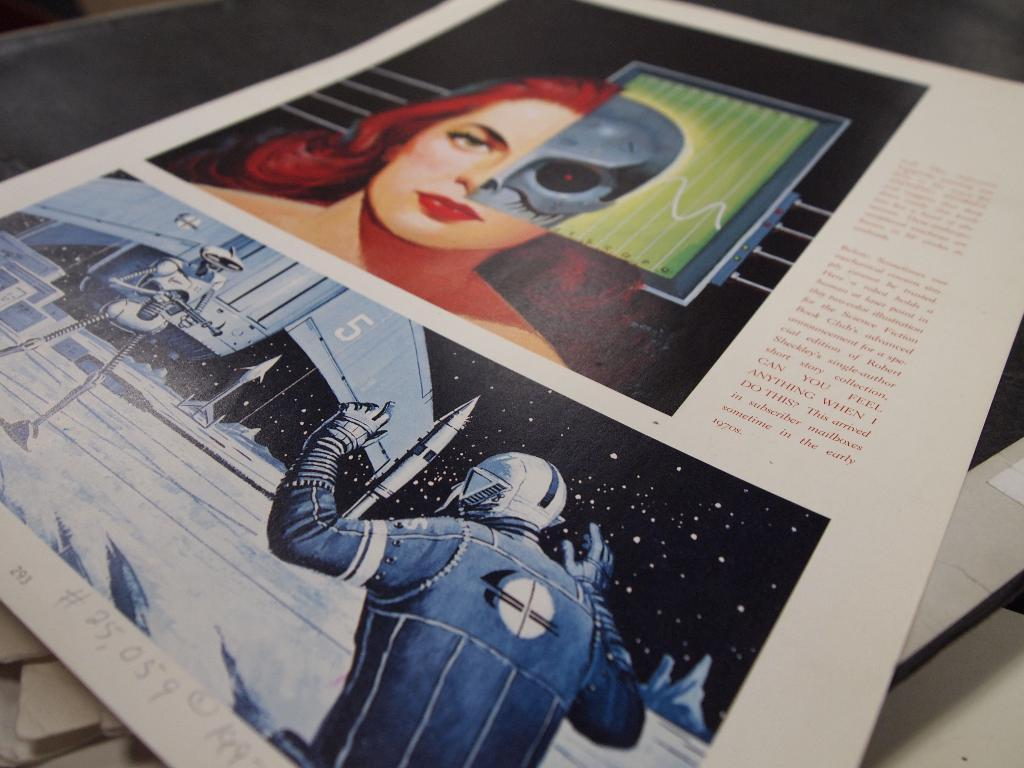What is on the table in the image? There is a paper on the table in the image. What is depicted on the paper? The paper contains a drawing of a robot woman, a person, a rocket, space, stars, and the ground. Where is the robot located in the image? The robot is on the left side of the image. What is the robot holding in the image? The robot is holding a gun. What type of vein can be seen in the image? There is no vein present in the image. What material is the chalk made of that the artist used to draw the robot woman? There is no information about the material used to draw the robot woman, and chalk is not mentioned in the facts. Is there a kite visible in the image? No, there is no kite present in the image. 